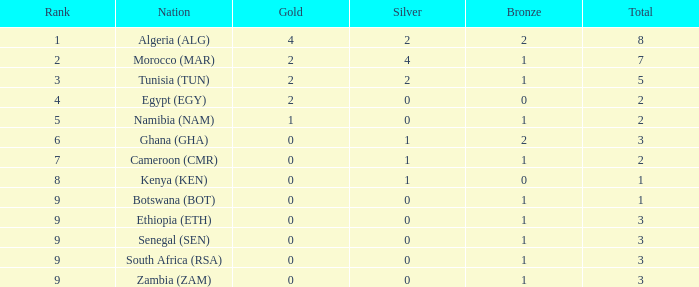What is the lowest Bronze with a Nation of egypt (egy) and with a Gold that is smaller than 2? None. 